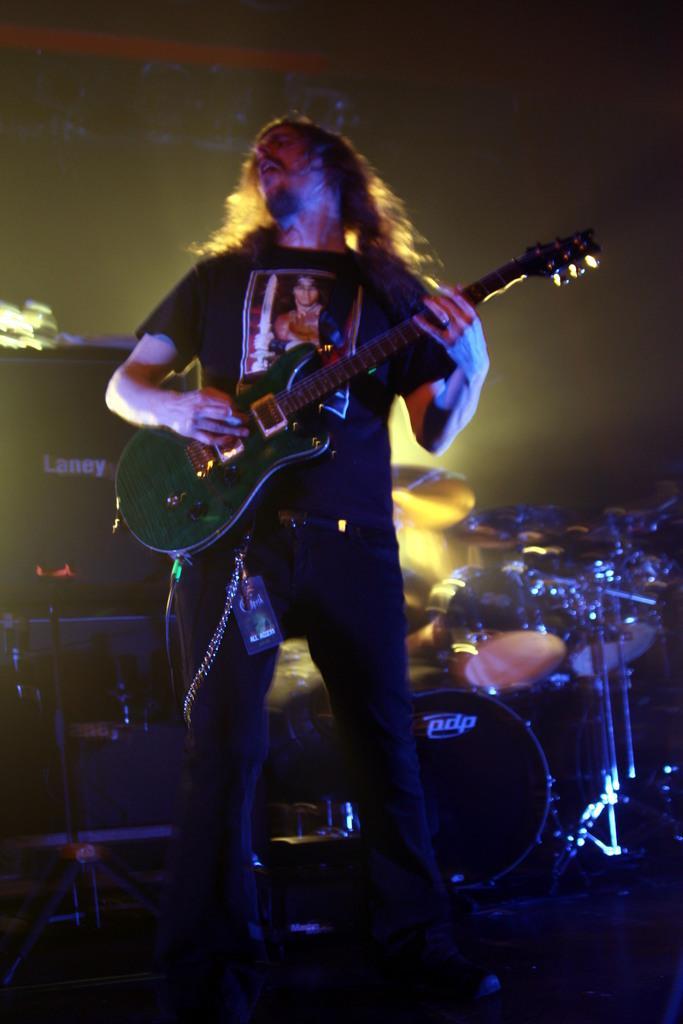How would you summarize this image in a sentence or two? In this image we can see a person playing a guitar, behind to him there are drums, and electronic objects, and the background is dark 